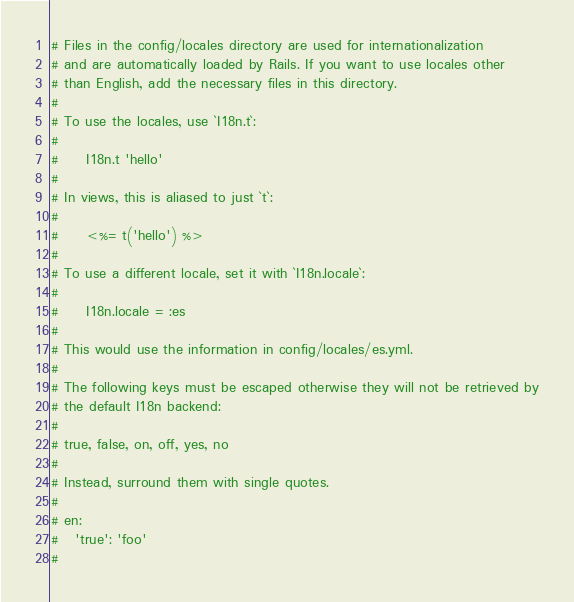Convert code to text. <code><loc_0><loc_0><loc_500><loc_500><_YAML_># Files in the config/locales directory are used for internationalization
# and are automatically loaded by Rails. If you want to use locales other
# than English, add the necessary files in this directory.
#
# To use the locales, use `I18n.t`:
#
#     I18n.t 'hello'
#
# In views, this is aliased to just `t`:
#
#     <%= t('hello') %>
#
# To use a different locale, set it with `I18n.locale`:
#
#     I18n.locale = :es
#
# This would use the information in config/locales/es.yml.
#
# The following keys must be escaped otherwise they will not be retrieved by
# the default I18n backend:
#
# true, false, on, off, yes, no
#
# Instead, surround them with single quotes.
#
# en:
#   'true': 'foo'
#</code> 